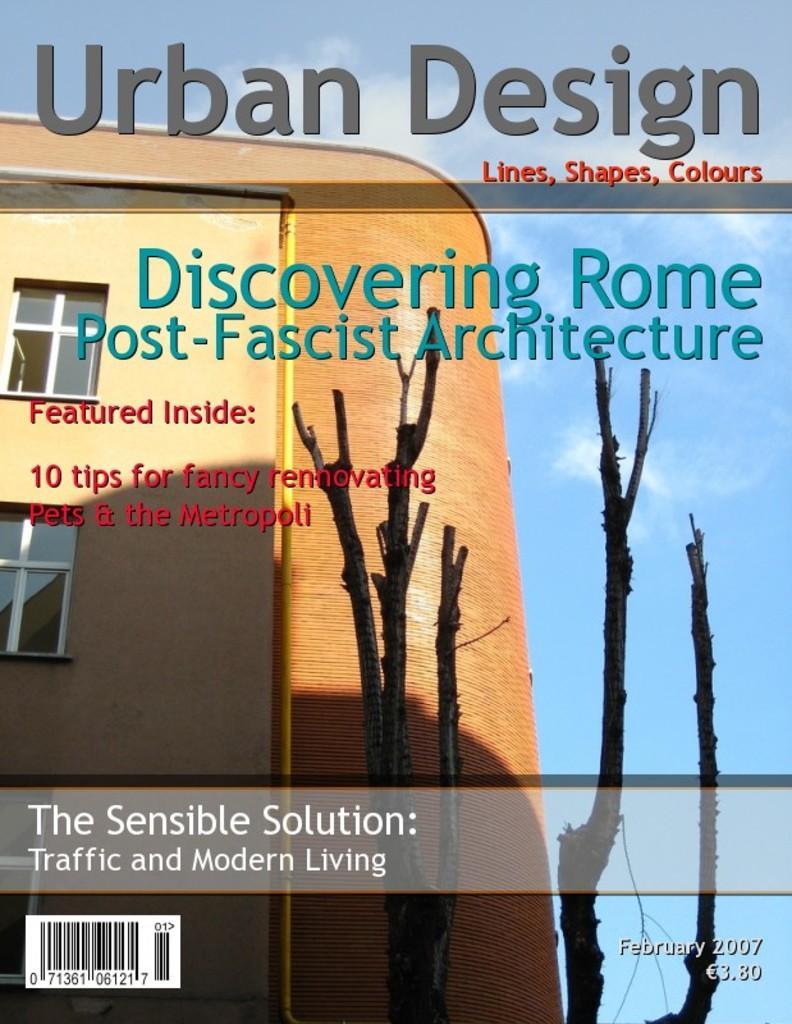How would you summarize this image in a sentence or two? In this picture we can see there is a building, a tree and the sky on the poster and on the poster it is written something. 